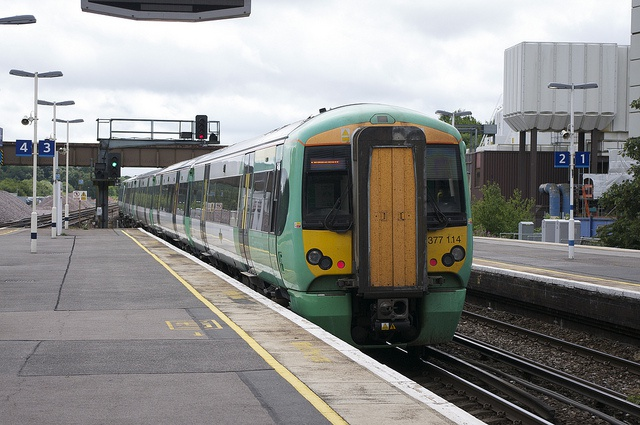Describe the objects in this image and their specific colors. I can see train in white, black, gray, olive, and darkgray tones, traffic light in white, black, and gray tones, traffic light in white, black, darkgray, and gray tones, and traffic light in white, black, lightgray, and gray tones in this image. 